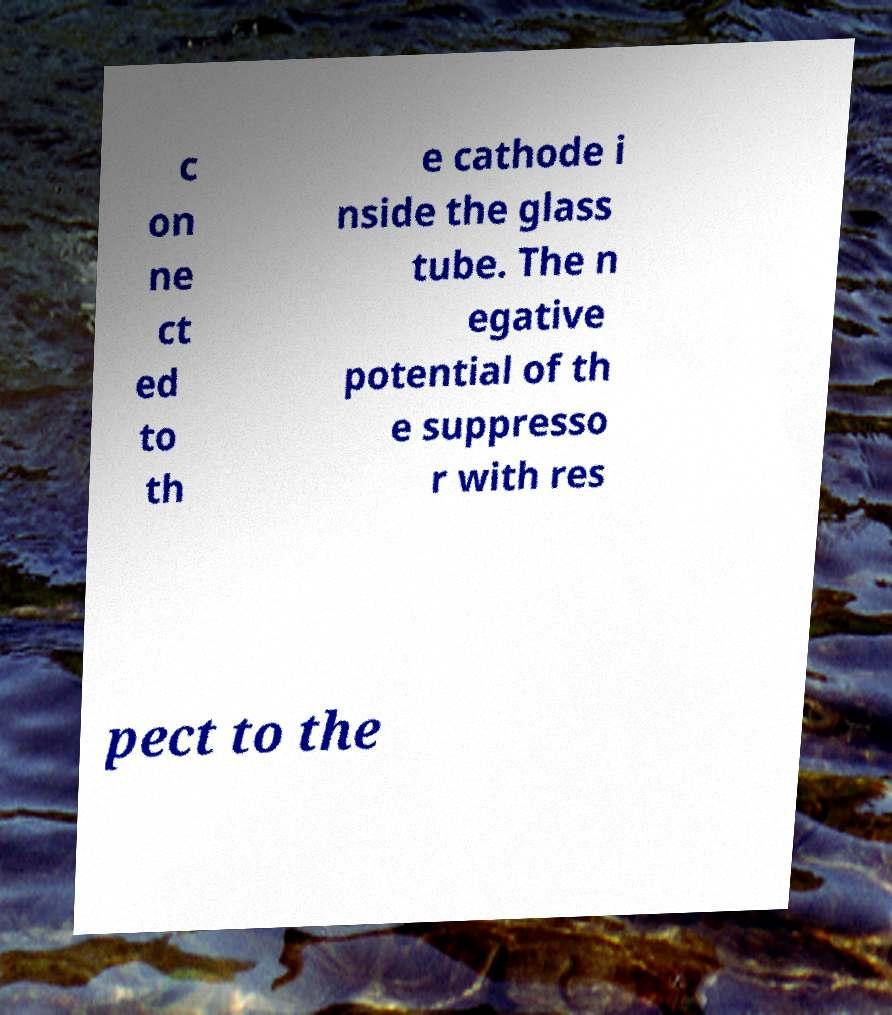I need the written content from this picture converted into text. Can you do that? c on ne ct ed to th e cathode i nside the glass tube. The n egative potential of th e suppresso r with res pect to the 